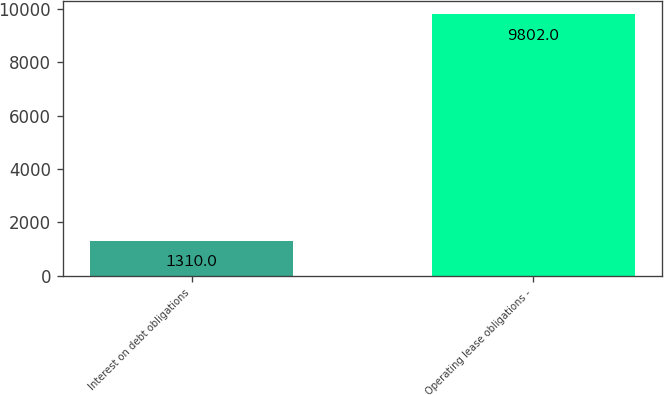<chart> <loc_0><loc_0><loc_500><loc_500><bar_chart><fcel>Interest on debt obligations<fcel>Operating lease obligations -<nl><fcel>1310<fcel>9802<nl></chart> 